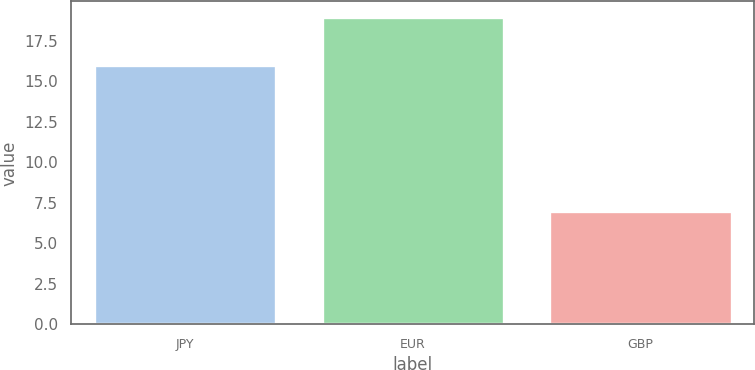Convert chart. <chart><loc_0><loc_0><loc_500><loc_500><bar_chart><fcel>JPY<fcel>EUR<fcel>GBP<nl><fcel>16<fcel>19<fcel>7<nl></chart> 